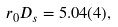<formula> <loc_0><loc_0><loc_500><loc_500>r _ { 0 } D _ { s } = 5 . 0 4 ( 4 ) ,</formula> 